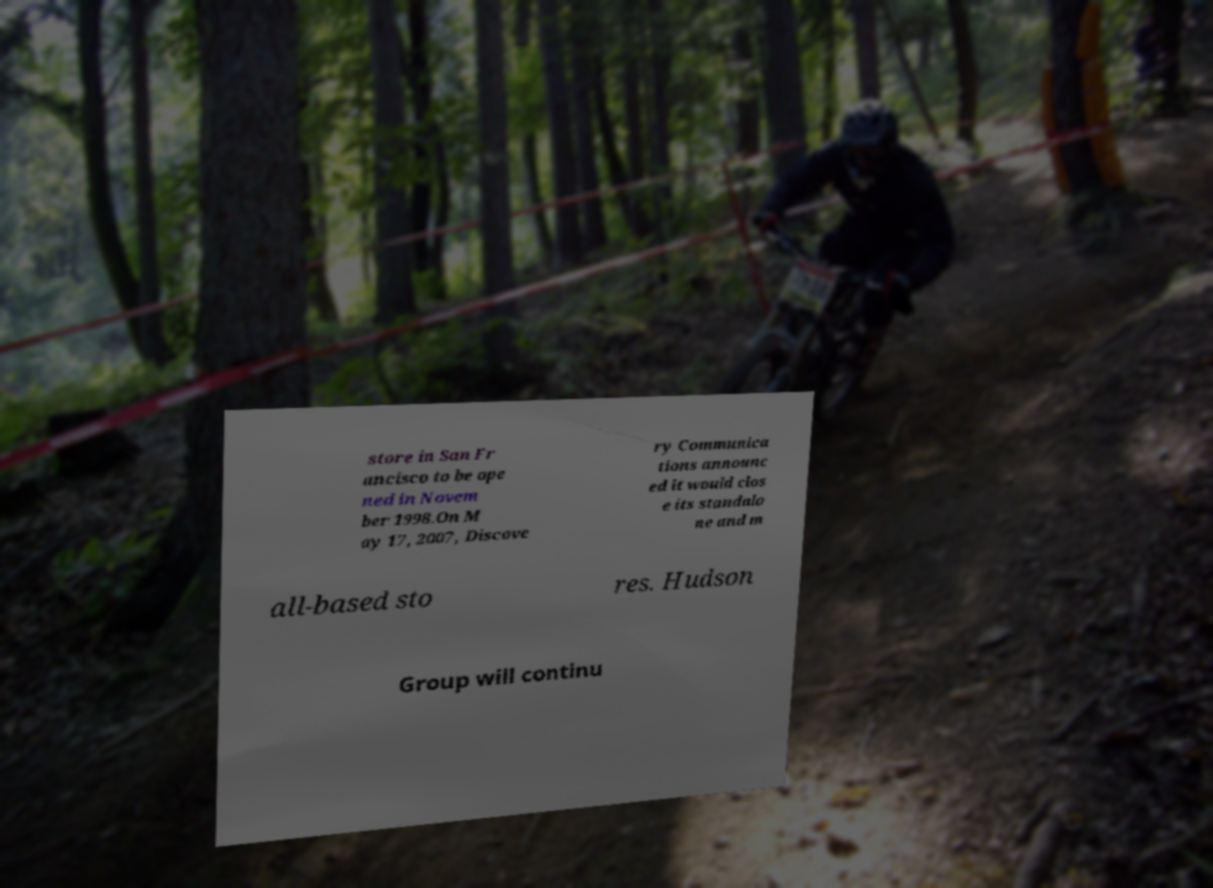Could you extract and type out the text from this image? store in San Fr ancisco to be ope ned in Novem ber 1998.On M ay 17, 2007, Discove ry Communica tions announc ed it would clos e its standalo ne and m all-based sto res. Hudson Group will continu 